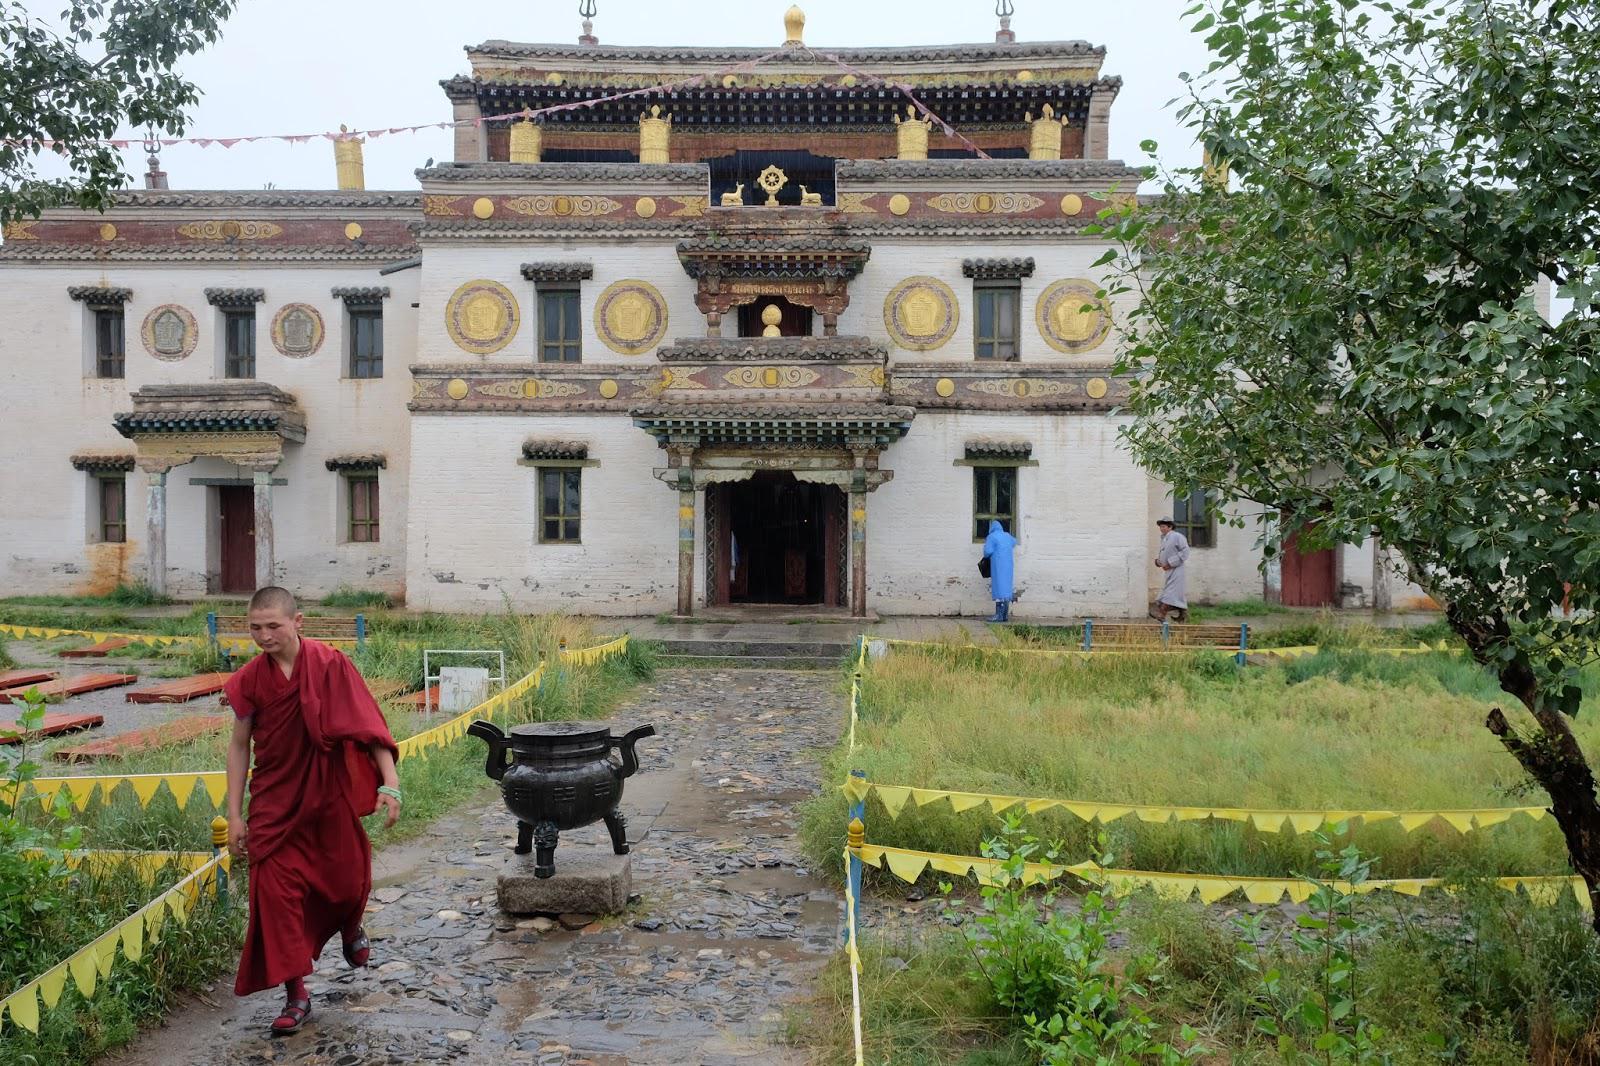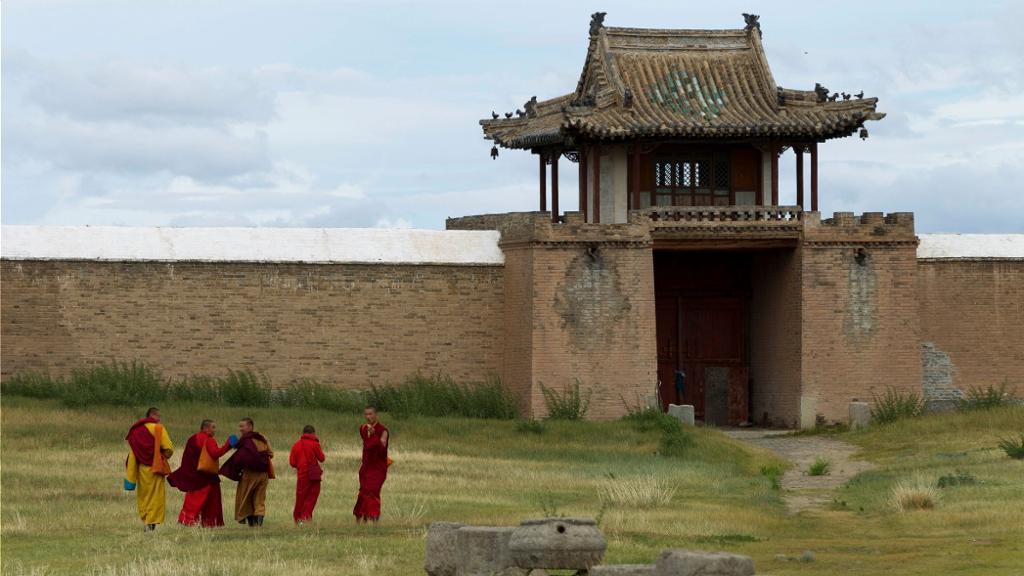The first image is the image on the left, the second image is the image on the right. Analyze the images presented: Is the assertion "A stone path with a cauldron-type item leads to a grand entrance of a temple in one image." valid? Answer yes or no. Yes. The first image is the image on the left, the second image is the image on the right. Given the left and right images, does the statement "At least one religious cross can be seen in one image." hold true? Answer yes or no. No. 